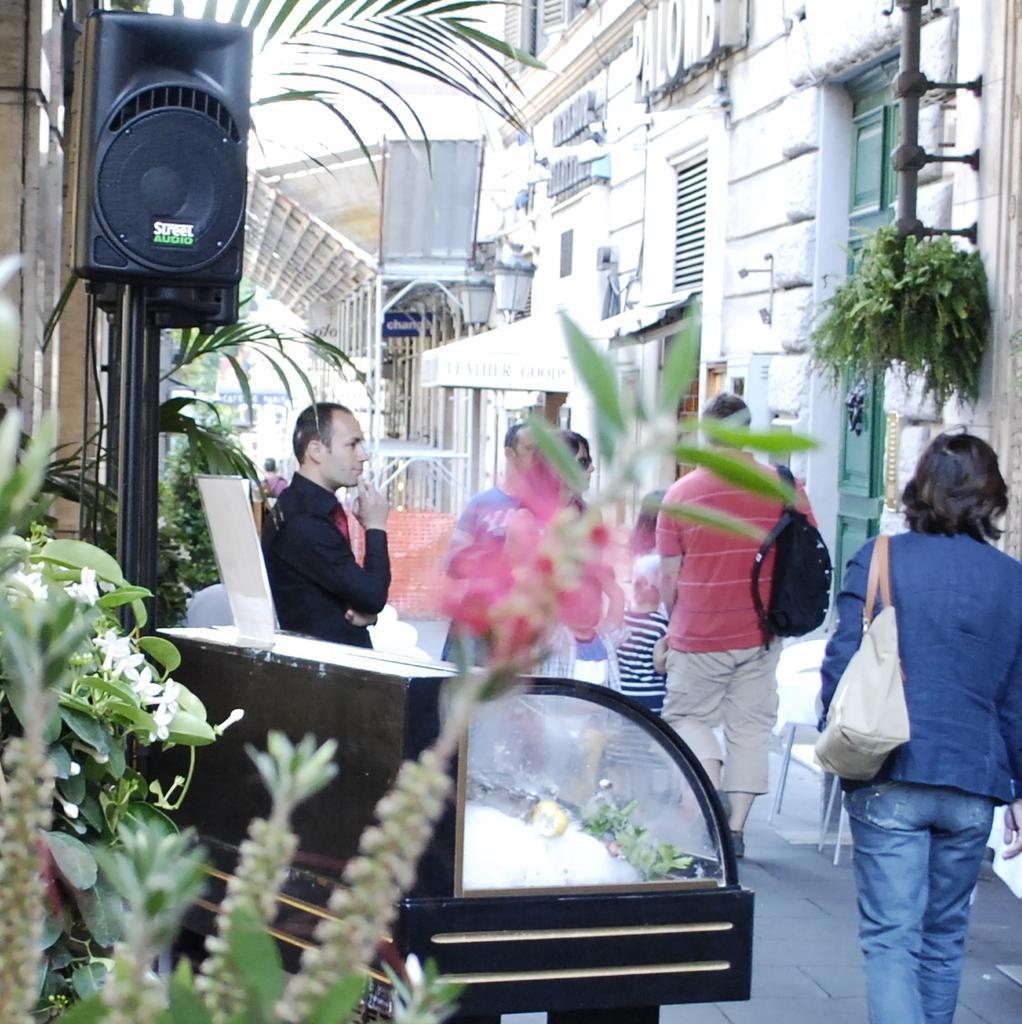Could you give a brief overview of what you see in this image? In this picture I can observe some people walking in this path. I can observe a black color speaker on the left side. There are some plants on either sides of the path. In the background there are buildings. 